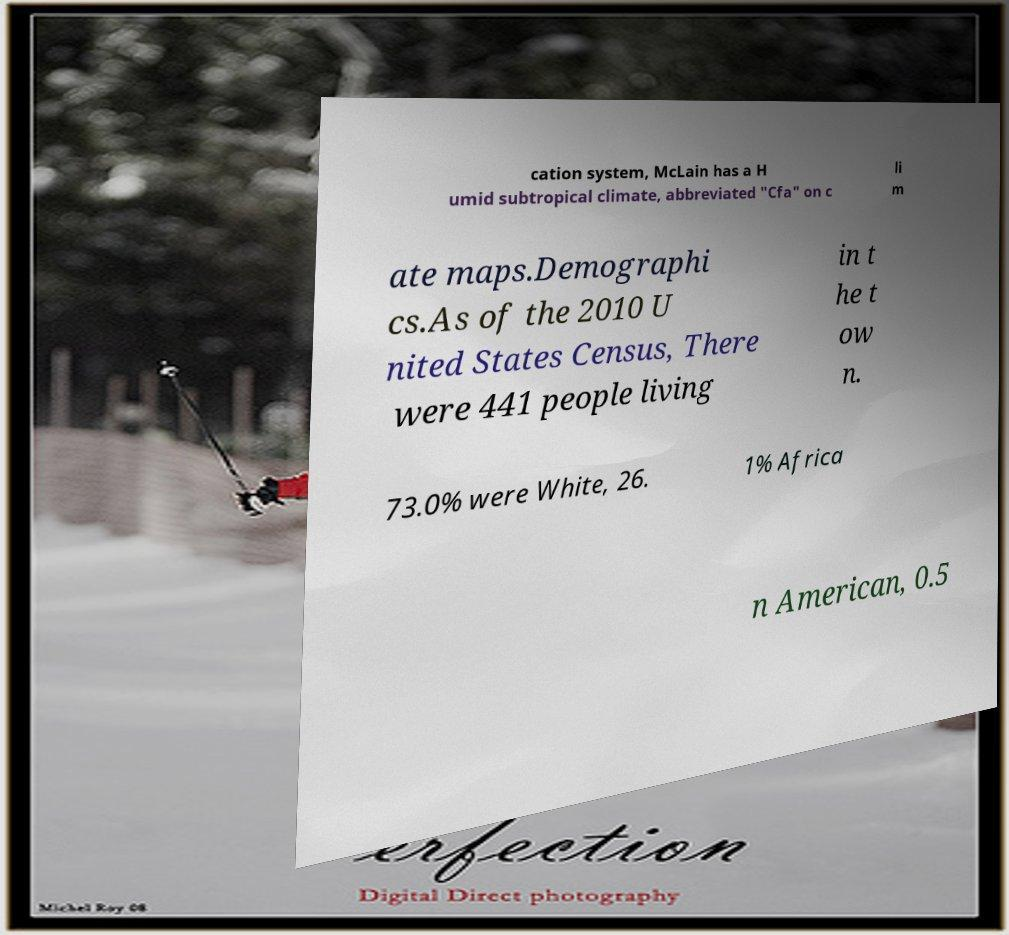Could you extract and type out the text from this image? cation system, McLain has a H umid subtropical climate, abbreviated "Cfa" on c li m ate maps.Demographi cs.As of the 2010 U nited States Census, There were 441 people living in t he t ow n. 73.0% were White, 26. 1% Africa n American, 0.5 